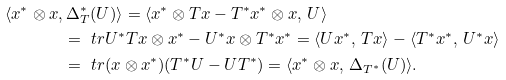<formula> <loc_0><loc_0><loc_500><loc_500>\langle x ^ { * } \otimes x , & \, \Delta _ { T } ^ { * } ( U ) \rangle = \langle x ^ { * } \otimes T x - T ^ { * } x ^ { * } \otimes x , \, U \rangle \\ & = \ t r { U ^ { * } T x \otimes x ^ { * } - U ^ { * } x \otimes T ^ { * } x ^ { * } } = \langle U x ^ { * } , \, T x \rangle - \langle T ^ { * } x ^ { * } , \, U ^ { * } x \rangle \\ & = \ t r { ( x \otimes x ^ { * } ) ( T ^ { * } U - U T ^ { * } ) } = \langle x ^ { * } \otimes x , \, \Delta _ { T ^ { * } } ( U ) \rangle .</formula> 